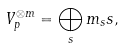Convert formula to latex. <formula><loc_0><loc_0><loc_500><loc_500>V _ { p } ^ { \otimes m } = \bigoplus _ { s } m _ { s } { s } ,</formula> 